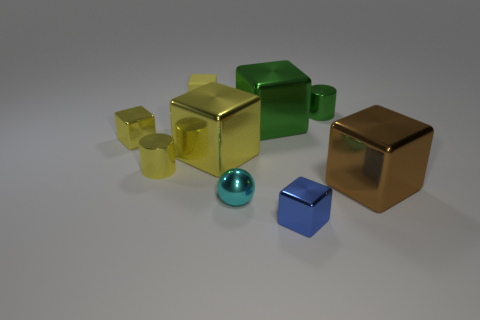What number of other things are the same material as the cyan thing?
Provide a short and direct response. 7. There is a metallic ball; is its size the same as the yellow metal block behind the big yellow cube?
Your response must be concise. Yes. The small ball is what color?
Your answer should be very brief. Cyan. What is the shape of the tiny yellow shiny object that is behind the yellow metallic object that is in front of the large block to the left of the tiny cyan thing?
Offer a very short reply. Cube. There is a small yellow cube left of the yellow block behind the small green shiny cylinder; what is it made of?
Make the answer very short. Metal. What shape is the tiny green thing that is made of the same material as the large green cube?
Offer a very short reply. Cylinder. Are there any other things that are the same shape as the cyan shiny object?
Provide a succinct answer. No. How many small shiny spheres are to the right of the small green metallic object?
Provide a succinct answer. 0. Are there any tiny purple metal blocks?
Offer a very short reply. No. There is a shiny cube that is behind the yellow block on the left side of the tiny yellow block that is behind the green shiny cylinder; what color is it?
Your answer should be very brief. Green. 